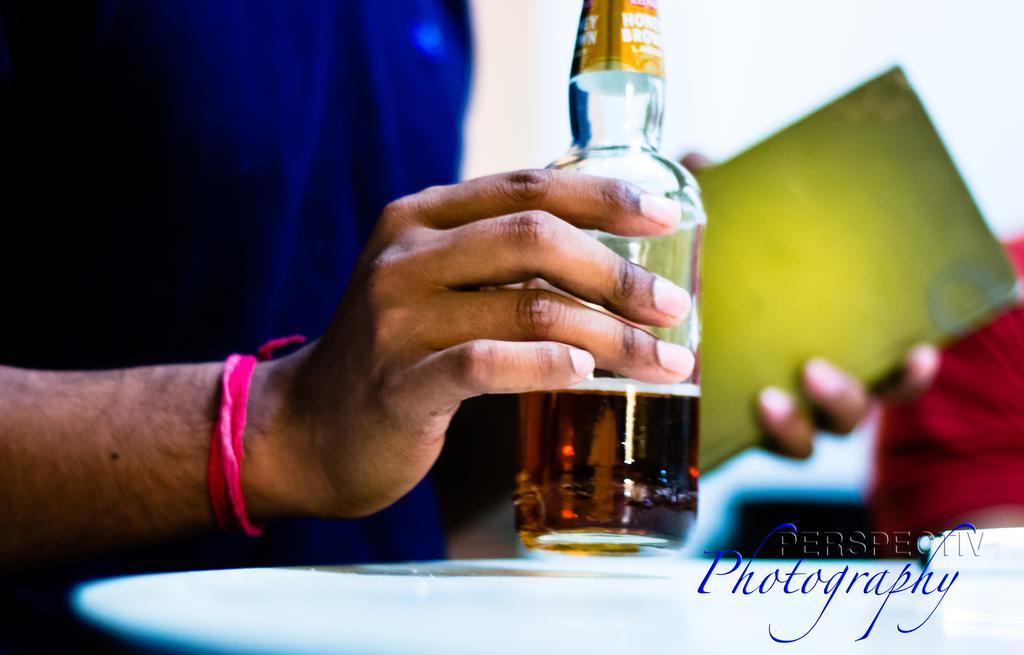<image>
Create a compact narrative representing the image presented. A person holding a half full beer bottle and Perspectiv Photography written in the corner. 